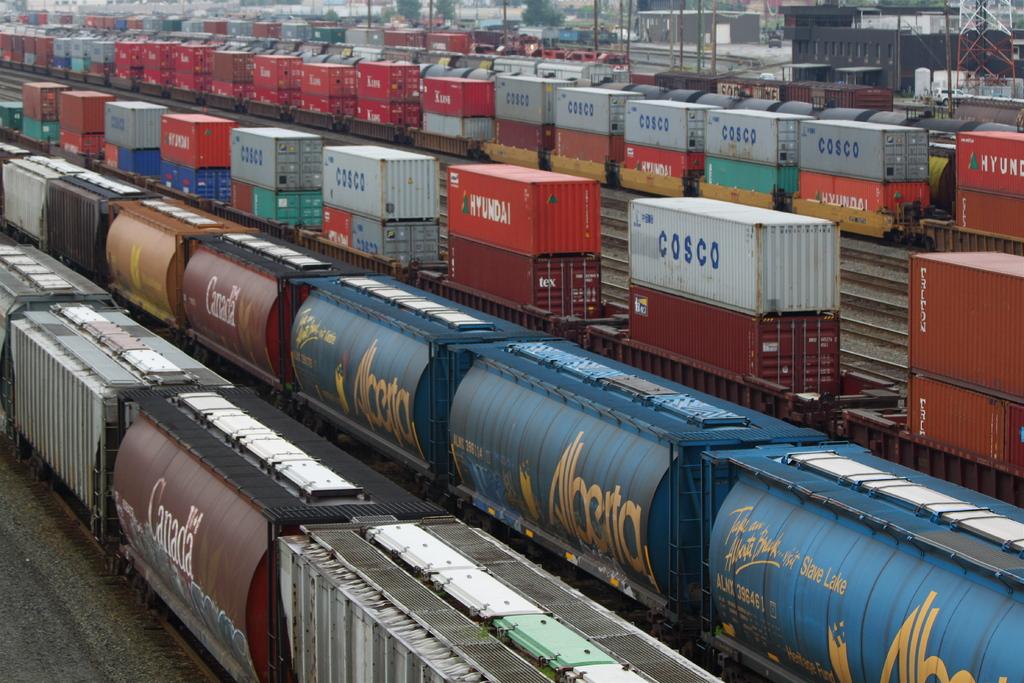What is the name on the train on the third row?
Keep it short and to the point. Cosco. What is written on the white containers?
Offer a very short reply. Cosco. 